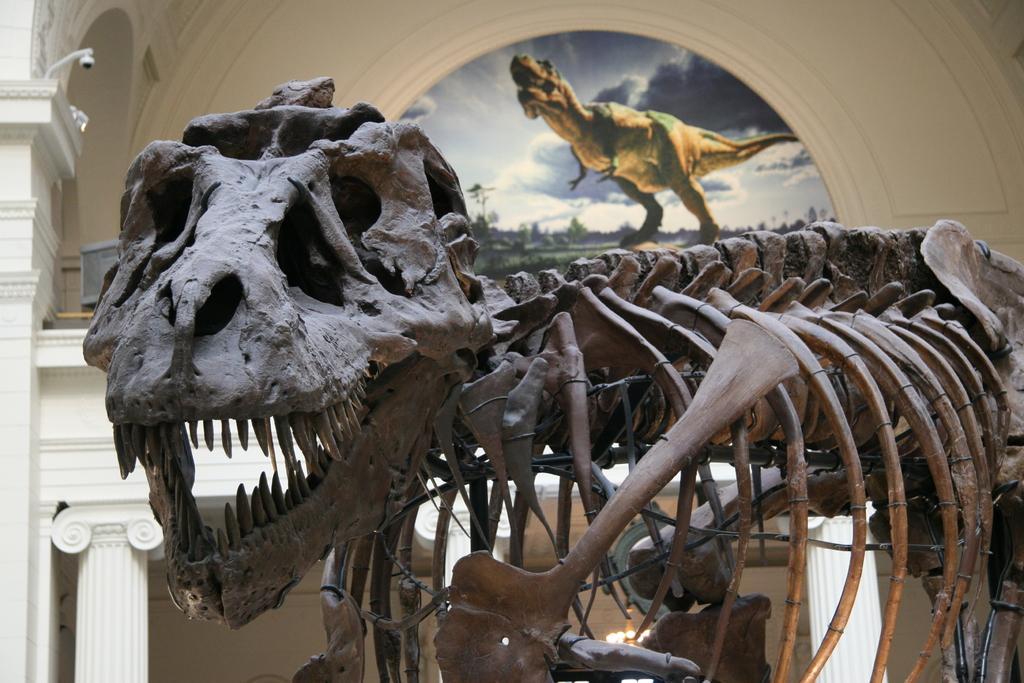In one or two sentences, can you explain what this image depicts? This picture shows a skeleton of a dinosaur and we see a poster. it is an inner view of a room. 